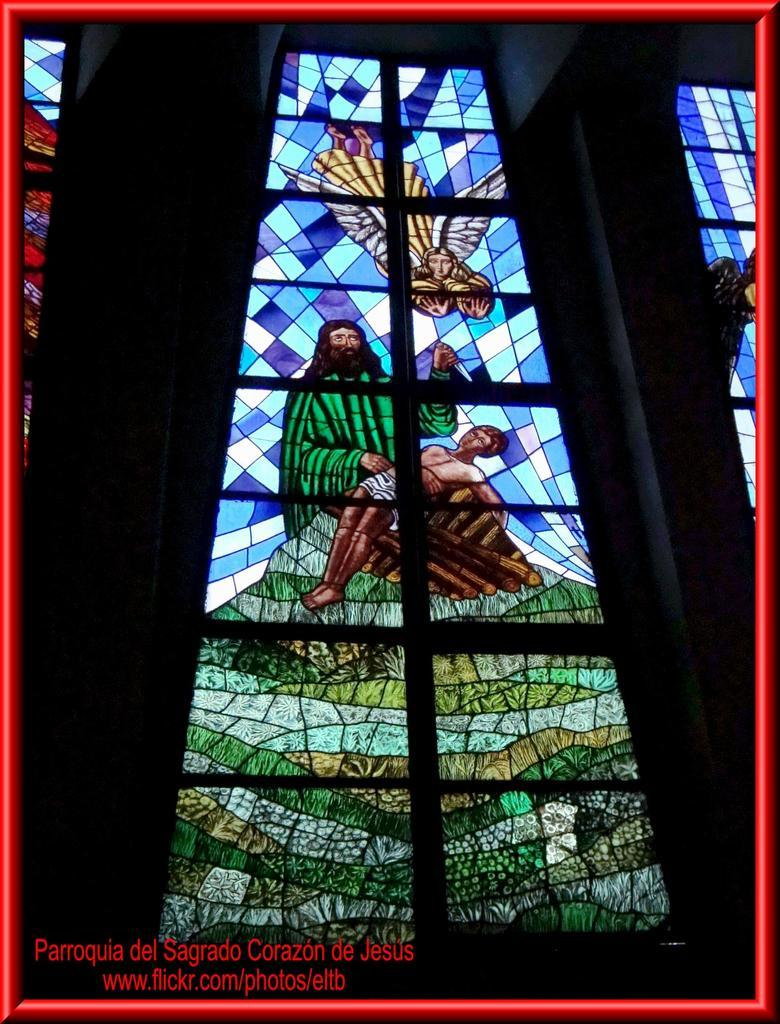What is the main subject of the image? The main subject of the image is a glass painting on the window glass. Can you describe the glass painting in more detail? Unfortunately, the details of the glass painting cannot be discerned from the provided fact. What is the purpose of the window glass in the image? The purpose of the window glass in the image is to display the glass painting. Can you tell me how many pets are visible in the image? There are no pets visible in the image, as the main subject is a glass painting on the window glass. Is there a kitty swinging from the window glass in the image? No, there is no kitty or swing present in the image; it only features a glass painting on the window glass. 